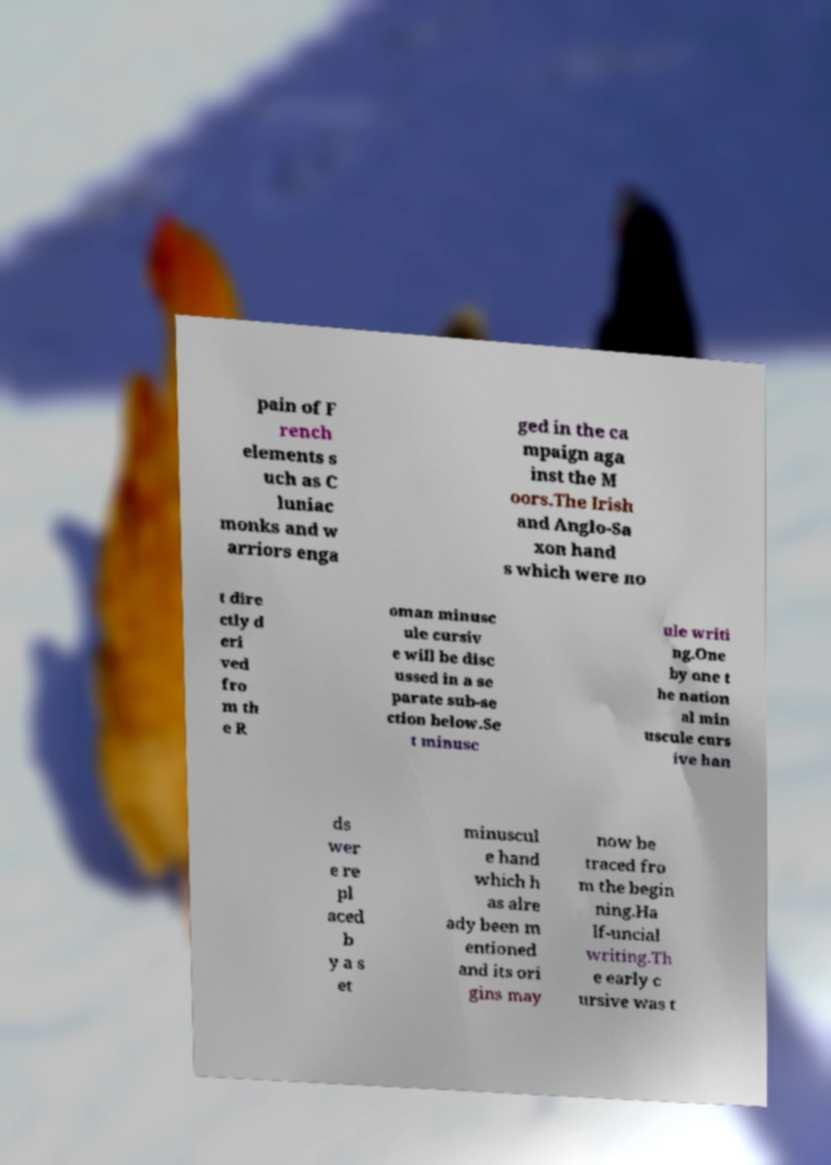Please read and relay the text visible in this image. What does it say? pain of F rench elements s uch as C luniac monks and w arriors enga ged in the ca mpaign aga inst the M oors.The Irish and Anglo-Sa xon hand s which were no t dire ctly d eri ved fro m th e R oman minusc ule cursiv e will be disc ussed in a se parate sub-se ction below.Se t minusc ule writi ng.One by one t he nation al min uscule curs ive han ds wer e re pl aced b y a s et minuscul e hand which h as alre ady been m entioned and its ori gins may now be traced fro m the begin ning.Ha lf-uncial writing.Th e early c ursive was t 